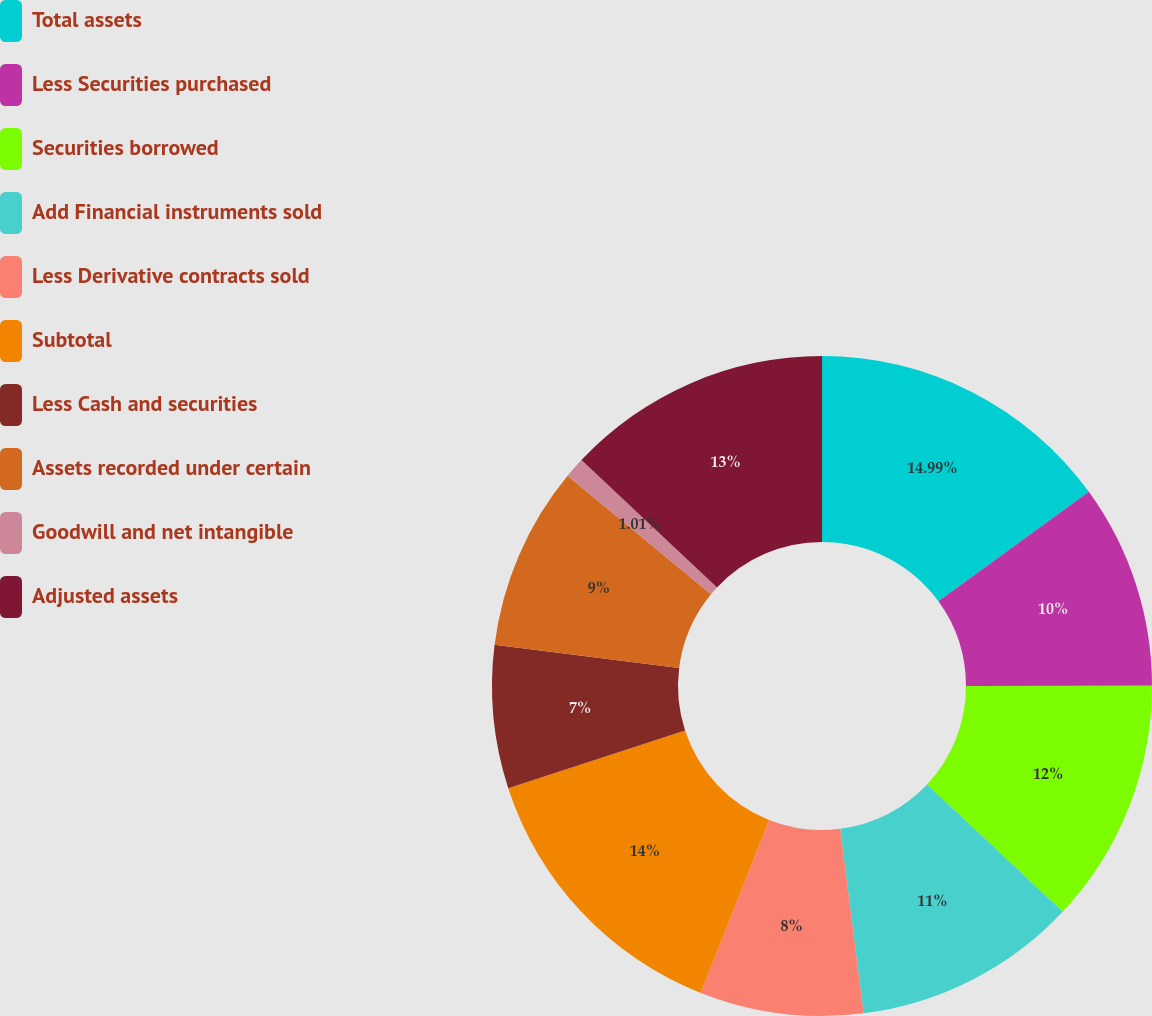Convert chart. <chart><loc_0><loc_0><loc_500><loc_500><pie_chart><fcel>Total assets<fcel>Less Securities purchased<fcel>Securities borrowed<fcel>Add Financial instruments sold<fcel>Less Derivative contracts sold<fcel>Subtotal<fcel>Less Cash and securities<fcel>Assets recorded under certain<fcel>Goodwill and net intangible<fcel>Adjusted assets<nl><fcel>14.99%<fcel>10.0%<fcel>12.0%<fcel>11.0%<fcel>8.0%<fcel>14.0%<fcel>7.0%<fcel>9.0%<fcel>1.01%<fcel>13.0%<nl></chart> 